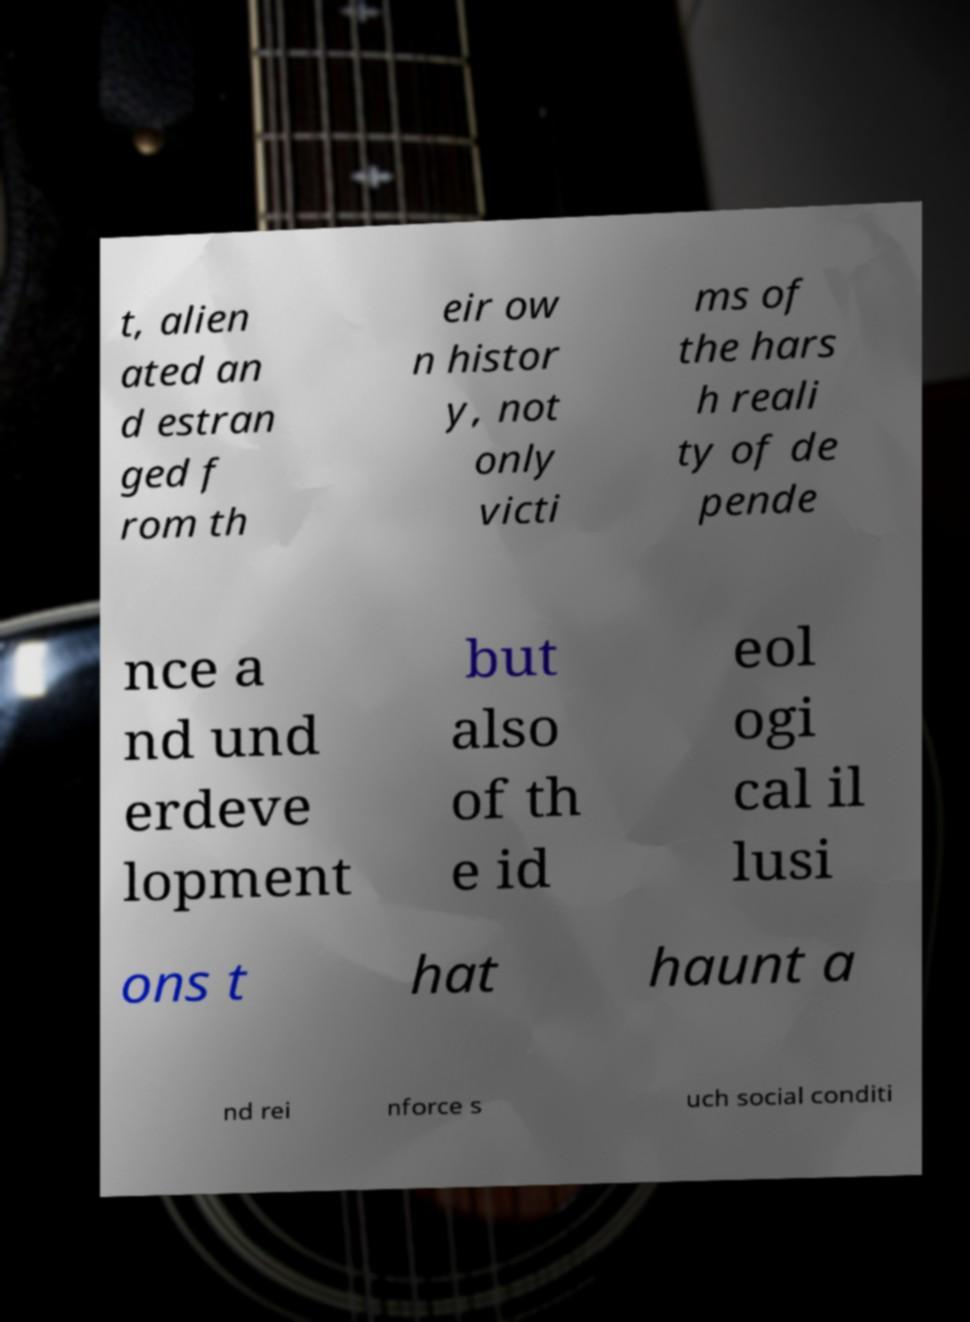Can you accurately transcribe the text from the provided image for me? t, alien ated an d estran ged f rom th eir ow n histor y, not only victi ms of the hars h reali ty of de pende nce a nd und erdeve lopment but also of th e id eol ogi cal il lusi ons t hat haunt a nd rei nforce s uch social conditi 